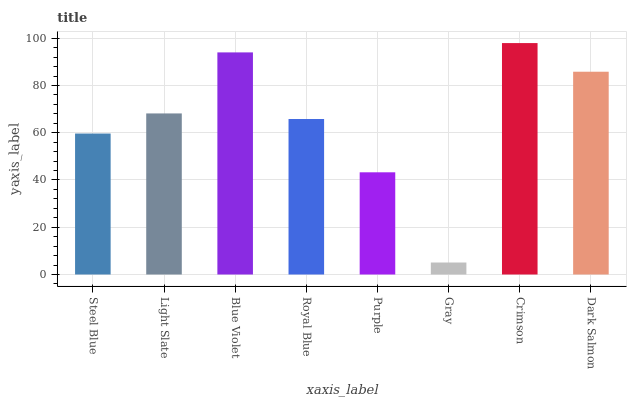Is Gray the minimum?
Answer yes or no. Yes. Is Crimson the maximum?
Answer yes or no. Yes. Is Light Slate the minimum?
Answer yes or no. No. Is Light Slate the maximum?
Answer yes or no. No. Is Light Slate greater than Steel Blue?
Answer yes or no. Yes. Is Steel Blue less than Light Slate?
Answer yes or no. Yes. Is Steel Blue greater than Light Slate?
Answer yes or no. No. Is Light Slate less than Steel Blue?
Answer yes or no. No. Is Light Slate the high median?
Answer yes or no. Yes. Is Royal Blue the low median?
Answer yes or no. Yes. Is Steel Blue the high median?
Answer yes or no. No. Is Purple the low median?
Answer yes or no. No. 